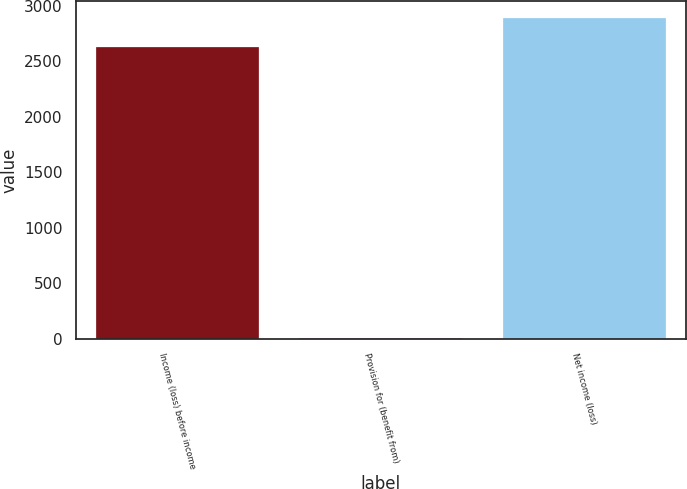Convert chart. <chart><loc_0><loc_0><loc_500><loc_500><bar_chart><fcel>Income (loss) before income<fcel>Provision for (benefit from)<fcel>Net income (loss)<nl><fcel>2631.8<fcel>1.8<fcel>2894.98<nl></chart> 